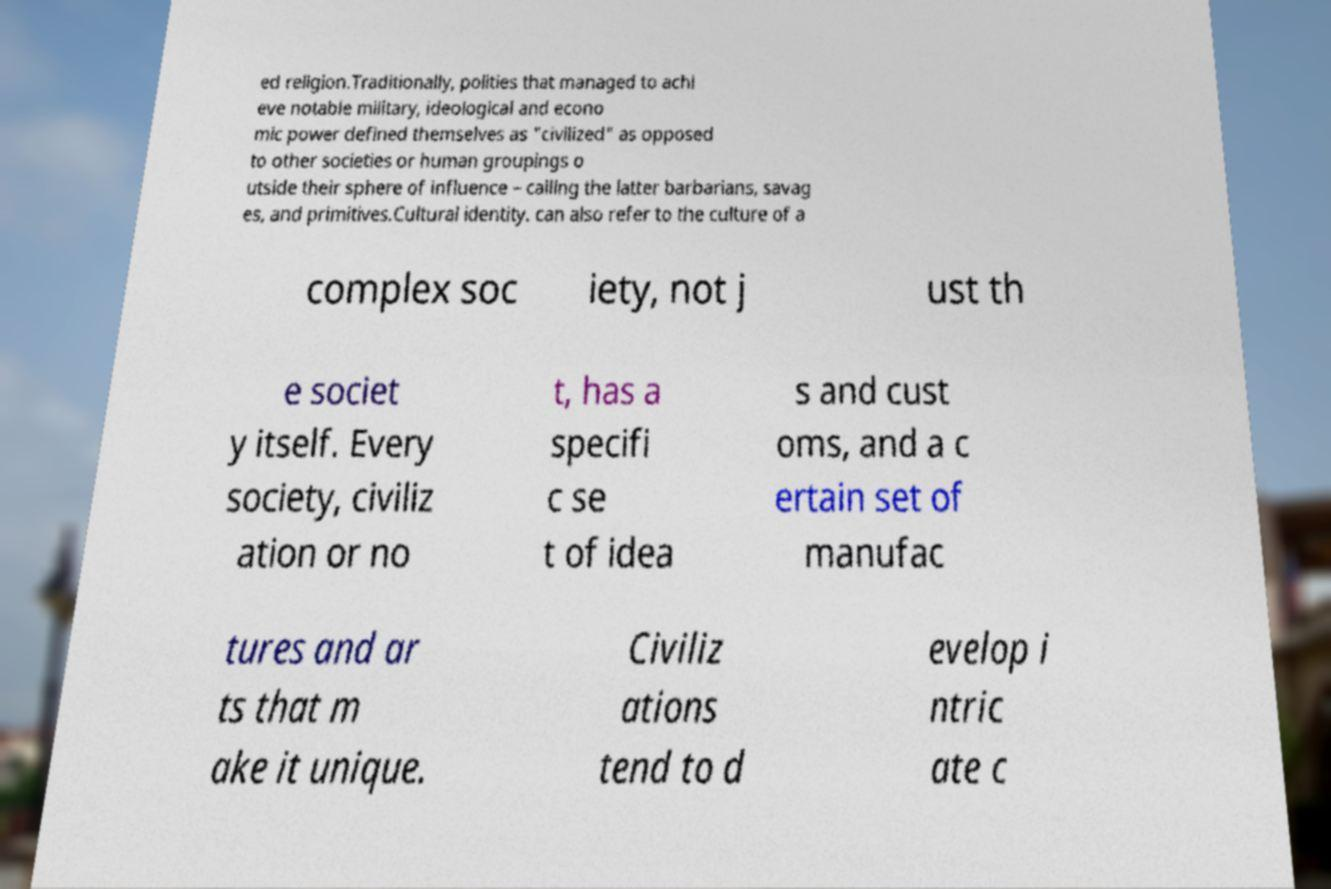There's text embedded in this image that I need extracted. Can you transcribe it verbatim? ed religion.Traditionally, polities that managed to achi eve notable military, ideological and econo mic power defined themselves as "civilized" as opposed to other societies or human groupings o utside their sphere of influence – calling the latter barbarians, savag es, and primitives.Cultural identity. can also refer to the culture of a complex soc iety, not j ust th e societ y itself. Every society, civiliz ation or no t, has a specifi c se t of idea s and cust oms, and a c ertain set of manufac tures and ar ts that m ake it unique. Civiliz ations tend to d evelop i ntric ate c 